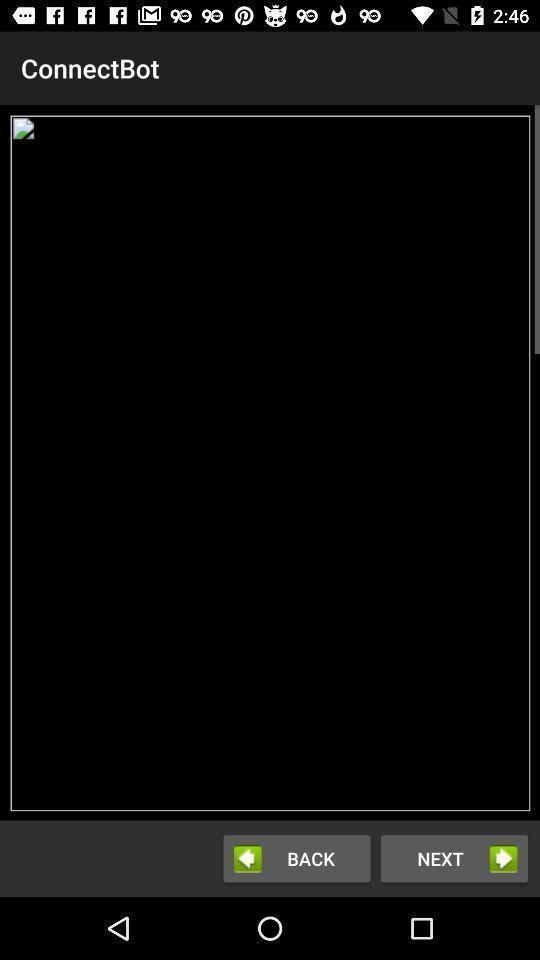Provide a description of this screenshot. Page displaying broken image with other options. 